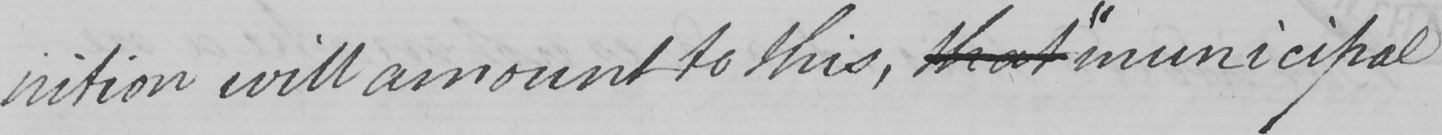Please transcribe the handwritten text in this image. nition will amount to this , that  " municipal 